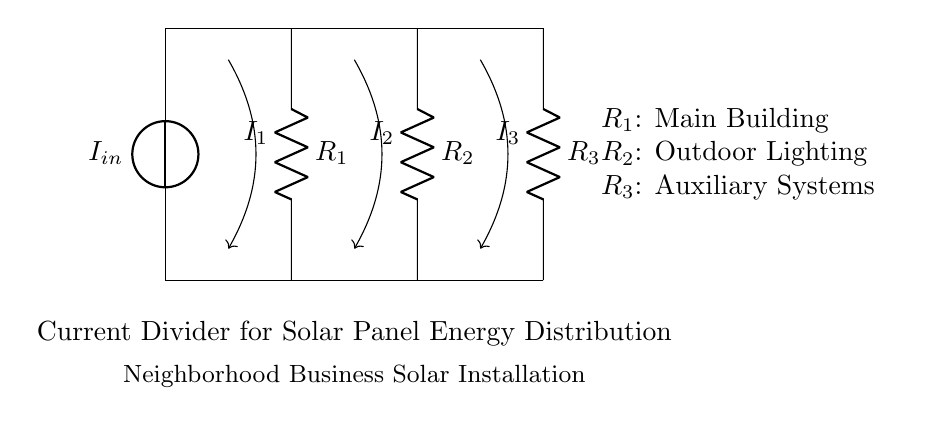What is the input current? The input current, labeled as \(I_{in}\), is the current entering the system from the voltage source. This value is typically determined based on the solar panel's output and is not specified in the diagram provided.
Answer: \(I_{in}\) How many resistors are in the circuit? There are three resistors in the circuit, labeled as \(R_1\), \(R_2\), and \(R_3\). This can be observed directly from the diagram as there are three distinct resistor symbols present.
Answer: 3 Which component represents the main building? The component representing the main building is labeled \(R_1\). It is the first resistor in the circuit, indicating that it absorbs a portion of the current in the divider.
Answer: \(R_1\) What is the relationship between \(I_1\), \(I_2\), and \(I_3\)? The relationship among \(I_1\), \(I_2\), and \(I_3\) is determined by the current divider rule, stating that the total current \(I_{in}\) is divided inversely according to the resistances. Therefore, \(I_1\), \(I_2\), and \(I_3\) are proportional to the inverses of \(R_1\), \(R_2\), and \(R_3\).
Answer: Proportional to inverses of resistances What does the current divider do? The current divider allows the total input current to be split among multiple branches or loads. In this circuit, it distributes the solar energy among the main building, outdoor lighting, and auxiliary systems according to their resistance values.
Answer: Distributes current What is the purpose of the current divider in this installation? The purpose of the current divider in this solar panel installation is to optimize energy distribution among different sections of the neighborhood business, ensuring that each part receives an appropriate share of the energy generated.
Answer: Optimize energy distribution 